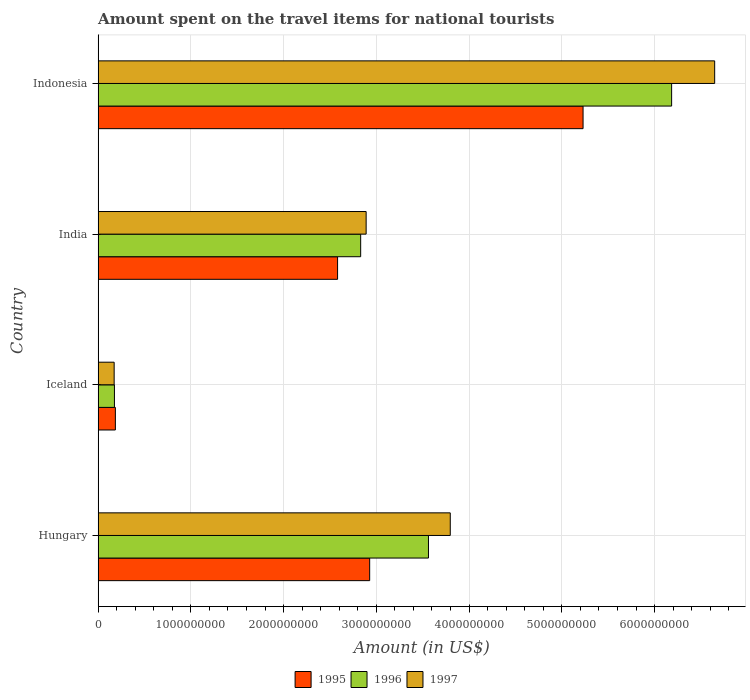How many groups of bars are there?
Provide a short and direct response. 4. Are the number of bars per tick equal to the number of legend labels?
Ensure brevity in your answer.  Yes. How many bars are there on the 1st tick from the top?
Provide a short and direct response. 3. How many bars are there on the 2nd tick from the bottom?
Keep it short and to the point. 3. What is the label of the 2nd group of bars from the top?
Offer a terse response. India. What is the amount spent on the travel items for national tourists in 1997 in Indonesia?
Offer a terse response. 6.65e+09. Across all countries, what is the maximum amount spent on the travel items for national tourists in 1997?
Provide a short and direct response. 6.65e+09. Across all countries, what is the minimum amount spent on the travel items for national tourists in 1996?
Offer a terse response. 1.76e+08. In which country was the amount spent on the travel items for national tourists in 1996 minimum?
Provide a succinct answer. Iceland. What is the total amount spent on the travel items for national tourists in 1995 in the graph?
Give a very brief answer. 1.09e+1. What is the difference between the amount spent on the travel items for national tourists in 1996 in Iceland and that in Indonesia?
Provide a succinct answer. -6.01e+09. What is the difference between the amount spent on the travel items for national tourists in 1996 in Indonesia and the amount spent on the travel items for national tourists in 1995 in Hungary?
Ensure brevity in your answer.  3.26e+09. What is the average amount spent on the travel items for national tourists in 1997 per country?
Offer a very short reply. 3.38e+09. What is the difference between the amount spent on the travel items for national tourists in 1996 and amount spent on the travel items for national tourists in 1997 in Indonesia?
Offer a very short reply. -4.64e+08. In how many countries, is the amount spent on the travel items for national tourists in 1996 greater than 1200000000 US$?
Offer a very short reply. 3. What is the ratio of the amount spent on the travel items for national tourists in 1996 in Hungary to that in Indonesia?
Make the answer very short. 0.58. What is the difference between the highest and the second highest amount spent on the travel items for national tourists in 1997?
Your response must be concise. 2.85e+09. What is the difference between the highest and the lowest amount spent on the travel items for national tourists in 1995?
Provide a short and direct response. 5.04e+09. In how many countries, is the amount spent on the travel items for national tourists in 1995 greater than the average amount spent on the travel items for national tourists in 1995 taken over all countries?
Offer a very short reply. 2. How many bars are there?
Ensure brevity in your answer.  12. How many countries are there in the graph?
Your response must be concise. 4. What is the difference between two consecutive major ticks on the X-axis?
Provide a short and direct response. 1.00e+09. Does the graph contain any zero values?
Your answer should be very brief. No. Does the graph contain grids?
Ensure brevity in your answer.  Yes. Where does the legend appear in the graph?
Give a very brief answer. Bottom center. What is the title of the graph?
Make the answer very short. Amount spent on the travel items for national tourists. Does "1967" appear as one of the legend labels in the graph?
Your response must be concise. No. What is the label or title of the Y-axis?
Your answer should be compact. Country. What is the Amount (in US$) of 1995 in Hungary?
Your response must be concise. 2.93e+09. What is the Amount (in US$) in 1996 in Hungary?
Keep it short and to the point. 3.56e+09. What is the Amount (in US$) in 1997 in Hungary?
Give a very brief answer. 3.80e+09. What is the Amount (in US$) of 1995 in Iceland?
Your answer should be very brief. 1.86e+08. What is the Amount (in US$) of 1996 in Iceland?
Ensure brevity in your answer.  1.76e+08. What is the Amount (in US$) in 1997 in Iceland?
Your response must be concise. 1.73e+08. What is the Amount (in US$) of 1995 in India?
Make the answer very short. 2.58e+09. What is the Amount (in US$) in 1996 in India?
Offer a terse response. 2.83e+09. What is the Amount (in US$) in 1997 in India?
Keep it short and to the point. 2.89e+09. What is the Amount (in US$) of 1995 in Indonesia?
Your answer should be very brief. 5.23e+09. What is the Amount (in US$) of 1996 in Indonesia?
Your answer should be very brief. 6.18e+09. What is the Amount (in US$) of 1997 in Indonesia?
Ensure brevity in your answer.  6.65e+09. Across all countries, what is the maximum Amount (in US$) in 1995?
Keep it short and to the point. 5.23e+09. Across all countries, what is the maximum Amount (in US$) of 1996?
Give a very brief answer. 6.18e+09. Across all countries, what is the maximum Amount (in US$) in 1997?
Offer a terse response. 6.65e+09. Across all countries, what is the minimum Amount (in US$) of 1995?
Keep it short and to the point. 1.86e+08. Across all countries, what is the minimum Amount (in US$) in 1996?
Provide a short and direct response. 1.76e+08. Across all countries, what is the minimum Amount (in US$) in 1997?
Give a very brief answer. 1.73e+08. What is the total Amount (in US$) in 1995 in the graph?
Offer a very short reply. 1.09e+1. What is the total Amount (in US$) in 1996 in the graph?
Make the answer very short. 1.28e+1. What is the total Amount (in US$) of 1997 in the graph?
Your answer should be very brief. 1.35e+1. What is the difference between the Amount (in US$) of 1995 in Hungary and that in Iceland?
Provide a short and direct response. 2.74e+09. What is the difference between the Amount (in US$) of 1996 in Hungary and that in Iceland?
Your response must be concise. 3.39e+09. What is the difference between the Amount (in US$) of 1997 in Hungary and that in Iceland?
Your response must be concise. 3.62e+09. What is the difference between the Amount (in US$) in 1995 in Hungary and that in India?
Provide a short and direct response. 3.46e+08. What is the difference between the Amount (in US$) in 1996 in Hungary and that in India?
Ensure brevity in your answer.  7.31e+08. What is the difference between the Amount (in US$) in 1997 in Hungary and that in India?
Provide a succinct answer. 9.07e+08. What is the difference between the Amount (in US$) in 1995 in Hungary and that in Indonesia?
Make the answer very short. -2.30e+09. What is the difference between the Amount (in US$) of 1996 in Hungary and that in Indonesia?
Keep it short and to the point. -2.62e+09. What is the difference between the Amount (in US$) in 1997 in Hungary and that in Indonesia?
Your response must be concise. -2.85e+09. What is the difference between the Amount (in US$) in 1995 in Iceland and that in India?
Keep it short and to the point. -2.40e+09. What is the difference between the Amount (in US$) of 1996 in Iceland and that in India?
Your answer should be very brief. -2.66e+09. What is the difference between the Amount (in US$) of 1997 in Iceland and that in India?
Your answer should be very brief. -2.72e+09. What is the difference between the Amount (in US$) of 1995 in Iceland and that in Indonesia?
Keep it short and to the point. -5.04e+09. What is the difference between the Amount (in US$) in 1996 in Iceland and that in Indonesia?
Ensure brevity in your answer.  -6.01e+09. What is the difference between the Amount (in US$) in 1997 in Iceland and that in Indonesia?
Provide a short and direct response. -6.48e+09. What is the difference between the Amount (in US$) in 1995 in India and that in Indonesia?
Keep it short and to the point. -2.65e+09. What is the difference between the Amount (in US$) of 1996 in India and that in Indonesia?
Keep it short and to the point. -3.35e+09. What is the difference between the Amount (in US$) of 1997 in India and that in Indonesia?
Offer a terse response. -3.76e+09. What is the difference between the Amount (in US$) in 1995 in Hungary and the Amount (in US$) in 1996 in Iceland?
Provide a succinct answer. 2.75e+09. What is the difference between the Amount (in US$) of 1995 in Hungary and the Amount (in US$) of 1997 in Iceland?
Give a very brief answer. 2.76e+09. What is the difference between the Amount (in US$) of 1996 in Hungary and the Amount (in US$) of 1997 in Iceland?
Your response must be concise. 3.39e+09. What is the difference between the Amount (in US$) in 1995 in Hungary and the Amount (in US$) in 1996 in India?
Give a very brief answer. 9.70e+07. What is the difference between the Amount (in US$) of 1995 in Hungary and the Amount (in US$) of 1997 in India?
Your response must be concise. 3.80e+07. What is the difference between the Amount (in US$) in 1996 in Hungary and the Amount (in US$) in 1997 in India?
Your answer should be very brief. 6.72e+08. What is the difference between the Amount (in US$) of 1995 in Hungary and the Amount (in US$) of 1996 in Indonesia?
Offer a terse response. -3.26e+09. What is the difference between the Amount (in US$) of 1995 in Hungary and the Amount (in US$) of 1997 in Indonesia?
Keep it short and to the point. -3.72e+09. What is the difference between the Amount (in US$) of 1996 in Hungary and the Amount (in US$) of 1997 in Indonesia?
Offer a very short reply. -3.09e+09. What is the difference between the Amount (in US$) in 1995 in Iceland and the Amount (in US$) in 1996 in India?
Ensure brevity in your answer.  -2.64e+09. What is the difference between the Amount (in US$) of 1995 in Iceland and the Amount (in US$) of 1997 in India?
Make the answer very short. -2.70e+09. What is the difference between the Amount (in US$) in 1996 in Iceland and the Amount (in US$) in 1997 in India?
Keep it short and to the point. -2.71e+09. What is the difference between the Amount (in US$) in 1995 in Iceland and the Amount (in US$) in 1996 in Indonesia?
Make the answer very short. -6.00e+09. What is the difference between the Amount (in US$) of 1995 in Iceland and the Amount (in US$) of 1997 in Indonesia?
Your answer should be very brief. -6.46e+09. What is the difference between the Amount (in US$) in 1996 in Iceland and the Amount (in US$) in 1997 in Indonesia?
Offer a very short reply. -6.47e+09. What is the difference between the Amount (in US$) in 1995 in India and the Amount (in US$) in 1996 in Indonesia?
Your answer should be very brief. -3.60e+09. What is the difference between the Amount (in US$) of 1995 in India and the Amount (in US$) of 1997 in Indonesia?
Give a very brief answer. -4.07e+09. What is the difference between the Amount (in US$) in 1996 in India and the Amount (in US$) in 1997 in Indonesia?
Make the answer very short. -3.82e+09. What is the average Amount (in US$) of 1995 per country?
Offer a very short reply. 2.73e+09. What is the average Amount (in US$) of 1996 per country?
Ensure brevity in your answer.  3.19e+09. What is the average Amount (in US$) in 1997 per country?
Make the answer very short. 3.38e+09. What is the difference between the Amount (in US$) in 1995 and Amount (in US$) in 1996 in Hungary?
Provide a succinct answer. -6.34e+08. What is the difference between the Amount (in US$) in 1995 and Amount (in US$) in 1997 in Hungary?
Provide a short and direct response. -8.69e+08. What is the difference between the Amount (in US$) of 1996 and Amount (in US$) of 1997 in Hungary?
Ensure brevity in your answer.  -2.35e+08. What is the difference between the Amount (in US$) of 1995 and Amount (in US$) of 1996 in Iceland?
Make the answer very short. 1.00e+07. What is the difference between the Amount (in US$) in 1995 and Amount (in US$) in 1997 in Iceland?
Give a very brief answer. 1.30e+07. What is the difference between the Amount (in US$) of 1995 and Amount (in US$) of 1996 in India?
Your answer should be very brief. -2.49e+08. What is the difference between the Amount (in US$) in 1995 and Amount (in US$) in 1997 in India?
Give a very brief answer. -3.08e+08. What is the difference between the Amount (in US$) of 1996 and Amount (in US$) of 1997 in India?
Your response must be concise. -5.90e+07. What is the difference between the Amount (in US$) of 1995 and Amount (in US$) of 1996 in Indonesia?
Give a very brief answer. -9.55e+08. What is the difference between the Amount (in US$) in 1995 and Amount (in US$) in 1997 in Indonesia?
Provide a succinct answer. -1.42e+09. What is the difference between the Amount (in US$) of 1996 and Amount (in US$) of 1997 in Indonesia?
Offer a terse response. -4.64e+08. What is the ratio of the Amount (in US$) of 1995 in Hungary to that in Iceland?
Your response must be concise. 15.74. What is the ratio of the Amount (in US$) of 1996 in Hungary to that in Iceland?
Your response must be concise. 20.24. What is the ratio of the Amount (in US$) in 1997 in Hungary to that in Iceland?
Your response must be concise. 21.95. What is the ratio of the Amount (in US$) in 1995 in Hungary to that in India?
Offer a very short reply. 1.13. What is the ratio of the Amount (in US$) of 1996 in Hungary to that in India?
Give a very brief answer. 1.26. What is the ratio of the Amount (in US$) of 1997 in Hungary to that in India?
Your response must be concise. 1.31. What is the ratio of the Amount (in US$) in 1995 in Hungary to that in Indonesia?
Your response must be concise. 0.56. What is the ratio of the Amount (in US$) in 1996 in Hungary to that in Indonesia?
Your answer should be compact. 0.58. What is the ratio of the Amount (in US$) of 1997 in Hungary to that in Indonesia?
Provide a succinct answer. 0.57. What is the ratio of the Amount (in US$) of 1995 in Iceland to that in India?
Keep it short and to the point. 0.07. What is the ratio of the Amount (in US$) of 1996 in Iceland to that in India?
Provide a succinct answer. 0.06. What is the ratio of the Amount (in US$) of 1997 in Iceland to that in India?
Your answer should be compact. 0.06. What is the ratio of the Amount (in US$) of 1995 in Iceland to that in Indonesia?
Your answer should be very brief. 0.04. What is the ratio of the Amount (in US$) of 1996 in Iceland to that in Indonesia?
Offer a very short reply. 0.03. What is the ratio of the Amount (in US$) in 1997 in Iceland to that in Indonesia?
Your answer should be compact. 0.03. What is the ratio of the Amount (in US$) of 1995 in India to that in Indonesia?
Your answer should be compact. 0.49. What is the ratio of the Amount (in US$) of 1996 in India to that in Indonesia?
Your answer should be very brief. 0.46. What is the ratio of the Amount (in US$) in 1997 in India to that in Indonesia?
Keep it short and to the point. 0.43. What is the difference between the highest and the second highest Amount (in US$) in 1995?
Offer a very short reply. 2.30e+09. What is the difference between the highest and the second highest Amount (in US$) of 1996?
Offer a terse response. 2.62e+09. What is the difference between the highest and the second highest Amount (in US$) of 1997?
Give a very brief answer. 2.85e+09. What is the difference between the highest and the lowest Amount (in US$) in 1995?
Offer a terse response. 5.04e+09. What is the difference between the highest and the lowest Amount (in US$) in 1996?
Keep it short and to the point. 6.01e+09. What is the difference between the highest and the lowest Amount (in US$) in 1997?
Your answer should be compact. 6.48e+09. 